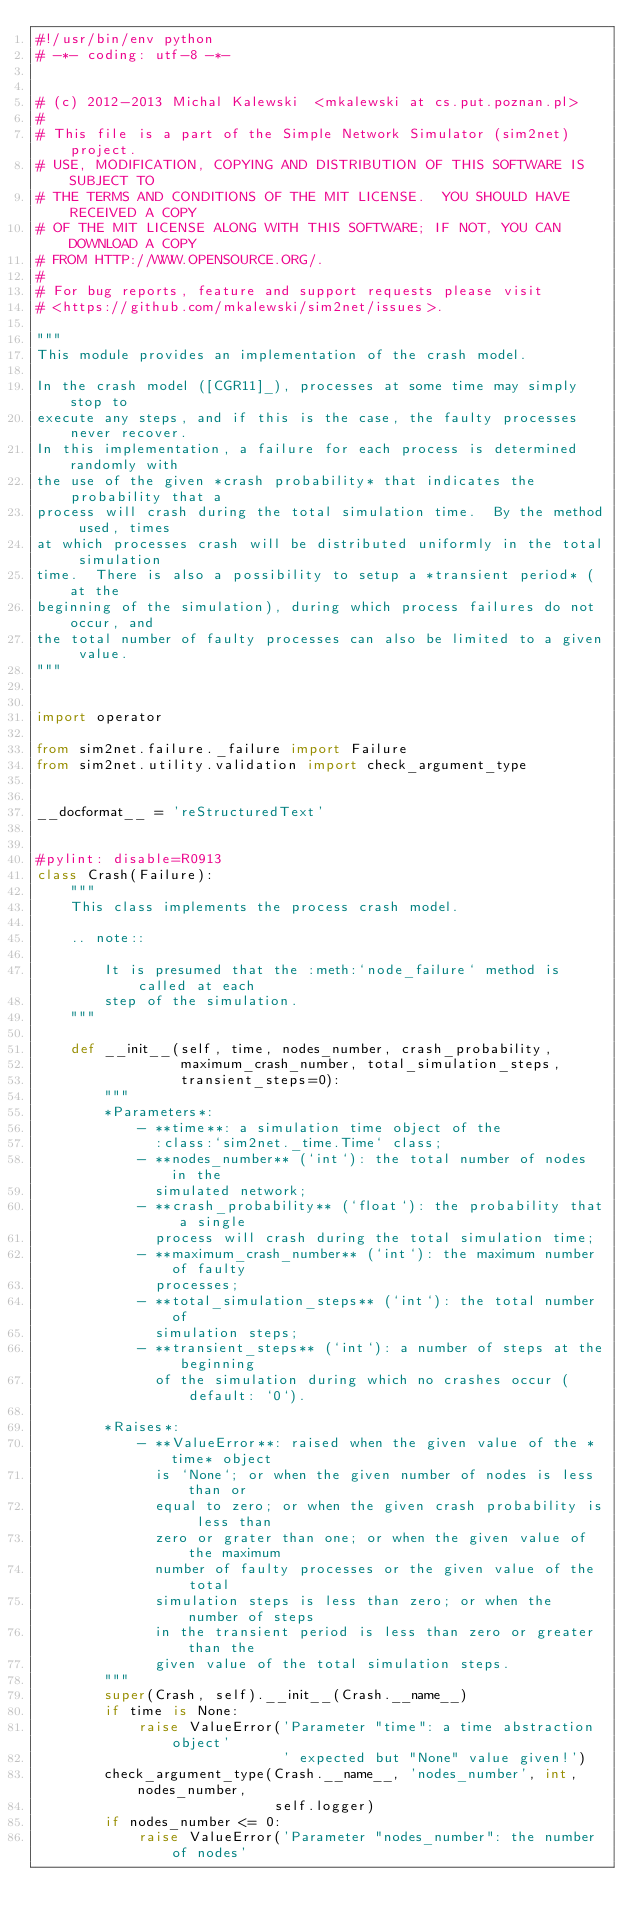<code> <loc_0><loc_0><loc_500><loc_500><_Python_>#!/usr/bin/env python
# -*- coding: utf-8 -*-


# (c) 2012-2013 Michal Kalewski  <mkalewski at cs.put.poznan.pl>
#
# This file is a part of the Simple Network Simulator (sim2net) project.
# USE, MODIFICATION, COPYING AND DISTRIBUTION OF THIS SOFTWARE IS SUBJECT TO
# THE TERMS AND CONDITIONS OF THE MIT LICENSE.  YOU SHOULD HAVE RECEIVED A COPY
# OF THE MIT LICENSE ALONG WITH THIS SOFTWARE; IF NOT, YOU CAN DOWNLOAD A COPY
# FROM HTTP://WWW.OPENSOURCE.ORG/.
#
# For bug reports, feature and support requests please visit
# <https://github.com/mkalewski/sim2net/issues>.

"""
This module provides an implementation of the crash model.

In the crash model ([CGR11]_), processes at some time may simply stop to
execute any steps, and if this is the case, the faulty processes never recover.
In this implementation, a failure for each process is determined randomly with
the use of the given *crash probability* that indicates the probability that a
process will crash during the total simulation time.  By the method used, times
at which processes crash will be distributed uniformly in the total simulation
time.  There is also a possibility to setup a *transient period* (at the
beginning of the simulation), during which process failures do not occur, and
the total number of faulty processes can also be limited to a given value.
"""


import operator

from sim2net.failure._failure import Failure
from sim2net.utility.validation import check_argument_type


__docformat__ = 'reStructuredText'


#pylint: disable=R0913
class Crash(Failure):
    """
    This class implements the process crash model.

    .. note::

        It is presumed that the :meth:`node_failure` method is called at each
        step of the simulation.
    """

    def __init__(self, time, nodes_number, crash_probability,
                 maximum_crash_number, total_simulation_steps,
                 transient_steps=0):
        """
        *Parameters*:
            - **time**: a simulation time object of the
              :class:`sim2net._time.Time` class;
            - **nodes_number** (`int`): the total number of nodes in the
              simulated network;
            - **crash_probability** (`float`): the probability that a single
              process will crash during the total simulation time;
            - **maximum_crash_number** (`int`): the maximum number of faulty
              processes;
            - **total_simulation_steps** (`int`): the total number of
              simulation steps;
            - **transient_steps** (`int`): a number of steps at the beginning
              of the simulation during which no crashes occur (default: `0`).

        *Raises*:
            - **ValueError**: raised when the given value of the *time* object
              is `None`; or when the given number of nodes is less than or
              equal to zero; or when the given crash probability is less than
              zero or grater than one; or when the given value of the maximum
              number of faulty processes or the given value of the total
              simulation steps is less than zero; or when the number of steps
              in the transient period is less than zero or greater than the
              given value of the total simulation steps.
        """
        super(Crash, self).__init__(Crash.__name__)
        if time is None:
            raise ValueError('Parameter "time": a time abstraction object'
                             ' expected but "None" value given!')
        check_argument_type(Crash.__name__, 'nodes_number', int, nodes_number,
                            self.logger)
        if nodes_number <= 0:
            raise ValueError('Parameter "nodes_number": the number of nodes'</code> 